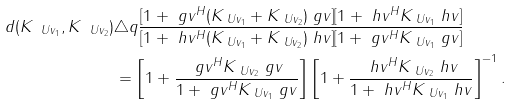<formula> <loc_0><loc_0><loc_500><loc_500>d ( K _ { \ U v _ { 1 } } , K _ { \ U v _ { 2 } } ) & \triangle q \frac { [ 1 + \ g v ^ { H } ( K _ { \ U v _ { 1 } } + K _ { \ U v _ { 2 } } ) \ g v ] [ 1 + \ h v ^ { H } K _ { \ U v _ { 1 } } \ h v ] } { [ 1 + \ h v ^ { H } ( K _ { \ U v _ { 1 } } + K _ { \ U v _ { 2 } } ) \ h v ] [ 1 + \ g v ^ { H } K _ { \ U v _ { 1 } } \ g v ] } \\ & = \left [ 1 + \frac { \ g v ^ { H } K _ { \ U v _ { 2 } } \ g v } { 1 + \ g v ^ { H } K _ { \ U v _ { 1 } } \ g v } \right ] \left [ 1 + \frac { \ h v ^ { H } K _ { \ U v _ { 2 } } \ h v } { 1 + \ h v ^ { H } K _ { \ U v _ { 1 } } \ h v } \right ] ^ { - 1 } .</formula> 